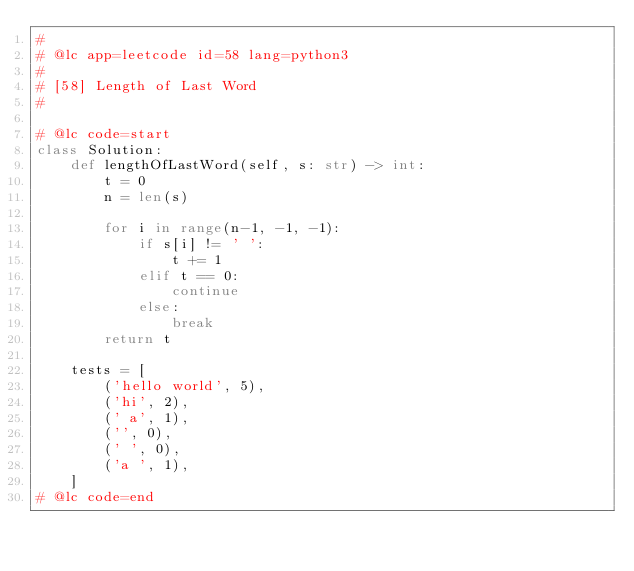<code> <loc_0><loc_0><loc_500><loc_500><_Python_>#
# @lc app=leetcode id=58 lang=python3
#
# [58] Length of Last Word
#

# @lc code=start
class Solution:
    def lengthOfLastWord(self, s: str) -> int:
        t = 0
        n = len(s)

        for i in range(n-1, -1, -1):
            if s[i] != ' ':
                t += 1
            elif t == 0:
                continue
            else:
                break
        return t

    tests = [
        ('hello world', 5),
        ('hi', 2),
        (' a', 1),
        ('', 0),
        (' ', 0),
        ('a ', 1),
    ]
# @lc code=end

</code> 